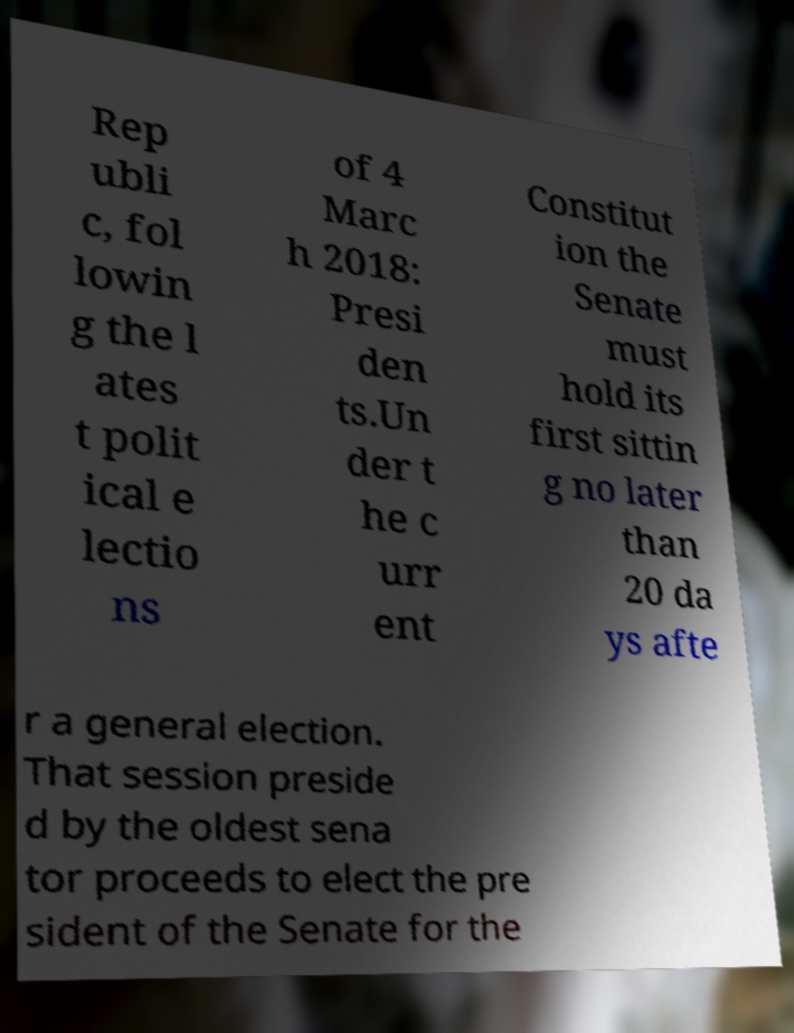Could you extract and type out the text from this image? Rep ubli c, fol lowin g the l ates t polit ical e lectio ns of 4 Marc h 2018: Presi den ts.Un der t he c urr ent Constitut ion the Senate must hold its first sittin g no later than 20 da ys afte r a general election. That session preside d by the oldest sena tor proceeds to elect the pre sident of the Senate for the 